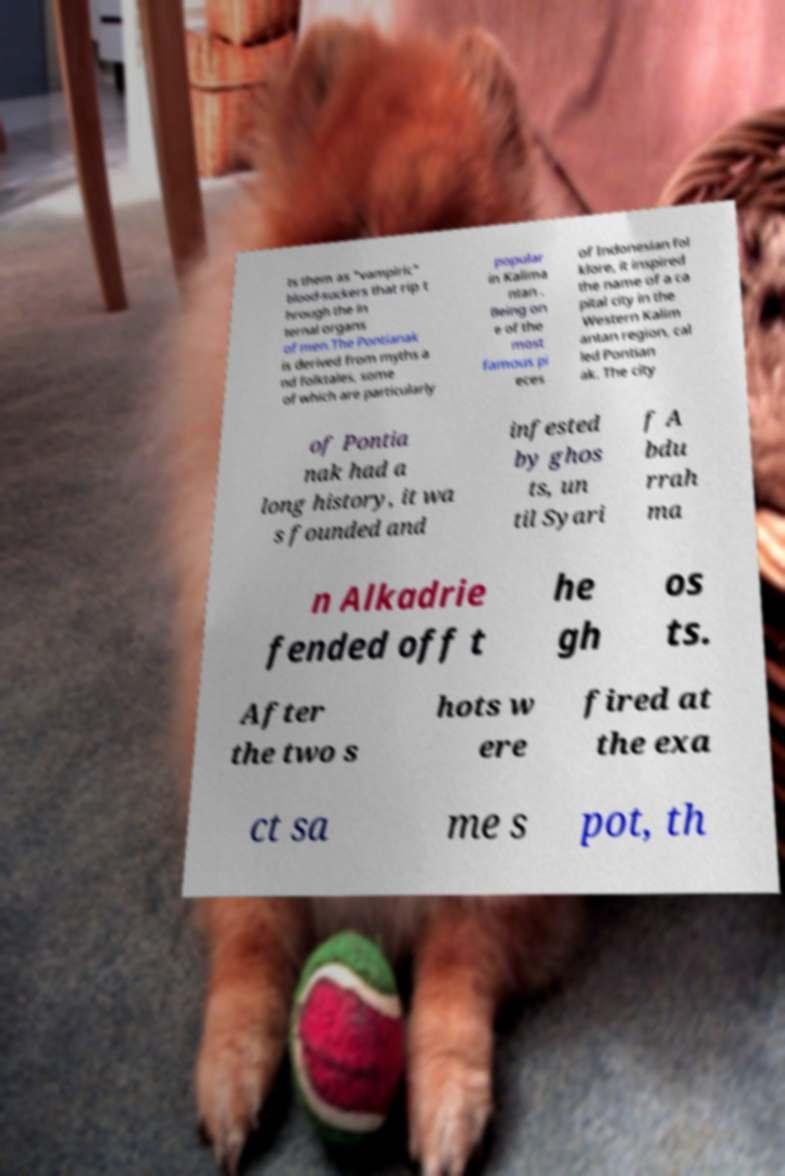For documentation purposes, I need the text within this image transcribed. Could you provide that? ts them as "vampiric" blood-suckers that rip t hrough the in ternal organs of men.The Pontianak is derived from myths a nd folktales, some of which are particularly popular in Kalima ntan . Being on e of the most famous pi eces of Indonesian fol klore, it inspired the name of a ca pital city in the Western Kalim antan region, cal led Pontian ak. The city of Pontia nak had a long history, it wa s founded and infested by ghos ts, un til Syari f A bdu rrah ma n Alkadrie fended off t he gh os ts. After the two s hots w ere fired at the exa ct sa me s pot, th 